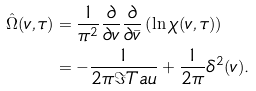Convert formula to latex. <formula><loc_0><loc_0><loc_500><loc_500>\hat { \Omega } ( v , \tau ) & = \frac { 1 } { \pi ^ { 2 } } \frac { \partial } { \partial v } \frac { \partial } { \partial \bar { v } } \left ( \ln \chi ( v , \tau ) \right ) \\ & = - \frac { 1 } { 2 \pi \Im T a u } + \frac { 1 } { 2 \pi } \delta ^ { 2 } ( v ) .</formula> 